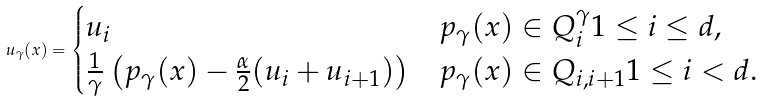Convert formula to latex. <formula><loc_0><loc_0><loc_500><loc_500>u _ { \gamma } ( x ) = \begin{cases} u _ { i } & p _ { \gamma } ( x ) \in Q _ { i } ^ { \gamma } 1 \leq i \leq d , \\ \frac { 1 } { \gamma } \left ( p _ { \gamma } ( x ) - \frac { \alpha } { 2 } ( u _ { i } + u _ { i + 1 } ) \right ) & p _ { \gamma } ( x ) \in Q _ { i , i + 1 } 1 \leq i < d . \end{cases}</formula> 